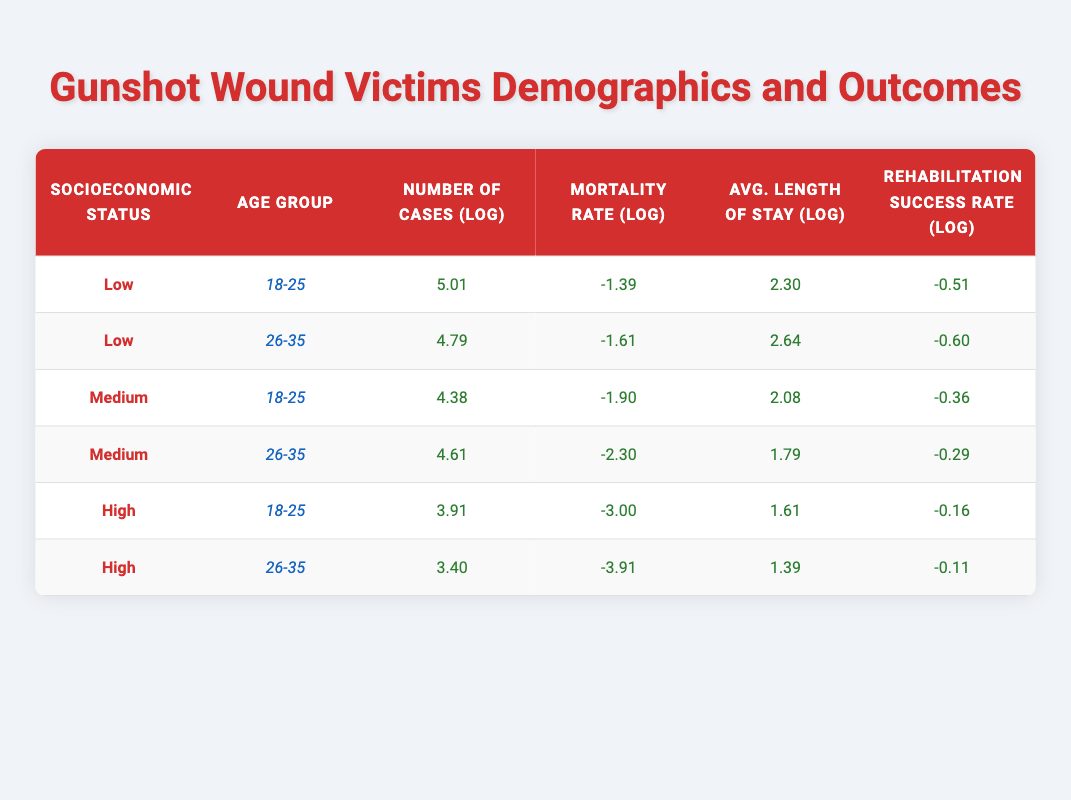What's the mortality rate for gunshot wound victims in the age group 18-25 with low socioeconomic status? The table shows the row for low socioeconomic status and the age group 18-25, where the mortality rate is listed as 0.25.
Answer: 0.25 What is the average length of stay in days for medium socioeconomic status gunshot wound victims aged 26-35? By looking at the row for medium socioeconomic status and age group 26-35, the average length of stay is recorded as 6 days.
Answer: 6 days Which age group for high socioeconomic status has the highest rehabilitation success rate? The rows for high socioeconomic status provide the rehabilitation success rates of 0.85 for age group 18-25 and 0.90 for age group 26-35. Since 0.90 is greater than 0.85, age group 26-35 has the highest success rate.
Answer: 26-35 What is the difference in the average length of stay between low and high socioeconomic status for age group 18-25? The average length of stay for low socioeconomic status (age group 18-25) is 10 days, while for high socioeconomic status, it is 5 days. The difference is 10 - 5 = 5 days.
Answer: 5 days True or false: The mortality rate for medium socioeconomic status gunshot victims aged 18-25 is higher than for low socioeconomic status victims in the same age group. The data shows a mortality rate of 0.15 for medium socioeconomic status and 0.25 for low socioeconomic status in the age group 18-25. Since 0.15 is less than 0.25, the statement is false.
Answer: False What is the total number of cases for low socioeconomic status across both age groups? The number of cases for low socioeconomic status in the age group 18-25 is 150, and for age group 26-35, it's 120. Summing these gives 150 + 120 = 270 cases total.
Answer: 270 What is the average rehabilitation success rate across all high socioeconomic status victims? The rehabilitation success rate for 18-25 is 0.85 and for 26-35 is 0.90. Adding these gives 0.85 + 0.90 = 1.75. To find the average, divide by 2: 1.75 / 2 = 0.875.
Answer: 0.875 In which socioeconomic status is the mortality rate the lowest for gunshot wound victims? Evaluating the mortality rates across all groups, low has 0.25, medium has 0.10, and high has 0.02. The lowest mortality rate is found in the high socioeconomic status group at 0.02.
Answer: High How many more cases are there in the age group 26-35 for low socioeconomic status compared to high socioeconomic status? The number of cases for low socioeconomic status in 26-35 is 120, while for high socioeconomic status, it is 30. The difference is calculated as 120 - 30 = 90.
Answer: 90 